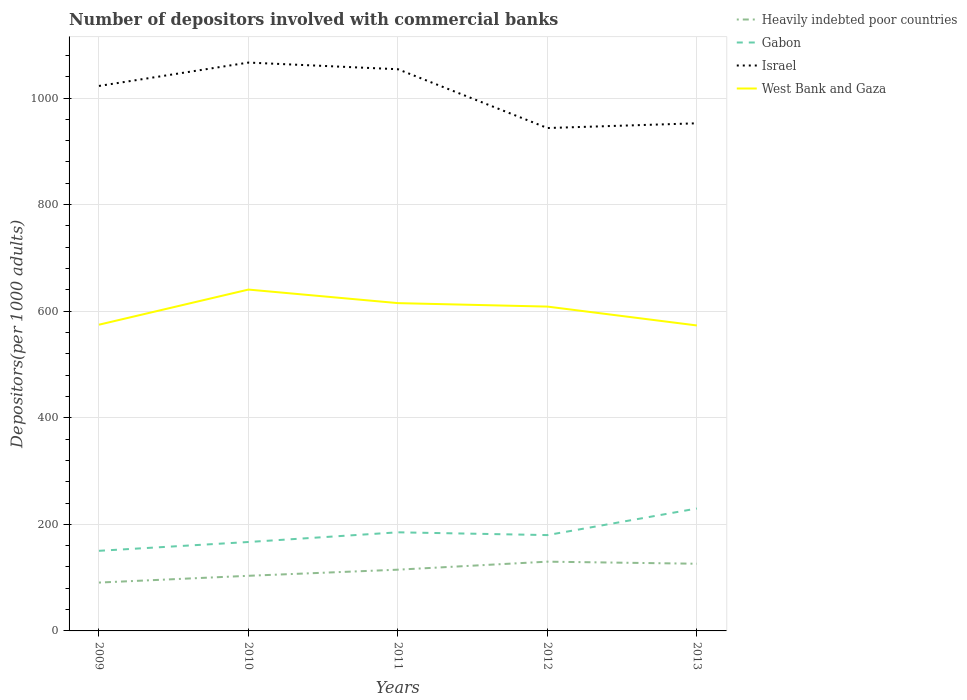How many different coloured lines are there?
Ensure brevity in your answer.  4. Does the line corresponding to Israel intersect with the line corresponding to Heavily indebted poor countries?
Make the answer very short. No. Across all years, what is the maximum number of depositors involved with commercial banks in West Bank and Gaza?
Provide a succinct answer. 573.23. In which year was the number of depositors involved with commercial banks in Israel maximum?
Offer a very short reply. 2012. What is the total number of depositors involved with commercial banks in West Bank and Gaza in the graph?
Your answer should be compact. -33.97. What is the difference between the highest and the second highest number of depositors involved with commercial banks in Gabon?
Offer a terse response. 79.41. Is the number of depositors involved with commercial banks in Israel strictly greater than the number of depositors involved with commercial banks in Heavily indebted poor countries over the years?
Provide a short and direct response. No. How many years are there in the graph?
Offer a terse response. 5. What is the difference between two consecutive major ticks on the Y-axis?
Offer a terse response. 200. Are the values on the major ticks of Y-axis written in scientific E-notation?
Provide a succinct answer. No. Does the graph contain grids?
Give a very brief answer. Yes. Where does the legend appear in the graph?
Ensure brevity in your answer.  Top right. How many legend labels are there?
Provide a short and direct response. 4. What is the title of the graph?
Give a very brief answer. Number of depositors involved with commercial banks. Does "Chile" appear as one of the legend labels in the graph?
Keep it short and to the point. No. What is the label or title of the X-axis?
Keep it short and to the point. Years. What is the label or title of the Y-axis?
Your answer should be very brief. Depositors(per 1000 adults). What is the Depositors(per 1000 adults) in Heavily indebted poor countries in 2009?
Give a very brief answer. 90.74. What is the Depositors(per 1000 adults) of Gabon in 2009?
Ensure brevity in your answer.  150.34. What is the Depositors(per 1000 adults) in Israel in 2009?
Offer a terse response. 1022.7. What is the Depositors(per 1000 adults) in West Bank and Gaza in 2009?
Your response must be concise. 574.67. What is the Depositors(per 1000 adults) of Heavily indebted poor countries in 2010?
Offer a terse response. 103.45. What is the Depositors(per 1000 adults) in Gabon in 2010?
Ensure brevity in your answer.  166.87. What is the Depositors(per 1000 adults) of Israel in 2010?
Provide a succinct answer. 1066.56. What is the Depositors(per 1000 adults) of West Bank and Gaza in 2010?
Keep it short and to the point. 640.58. What is the Depositors(per 1000 adults) in Heavily indebted poor countries in 2011?
Provide a short and direct response. 114.93. What is the Depositors(per 1000 adults) in Gabon in 2011?
Your answer should be very brief. 185.06. What is the Depositors(per 1000 adults) of Israel in 2011?
Make the answer very short. 1054.06. What is the Depositors(per 1000 adults) of West Bank and Gaza in 2011?
Give a very brief answer. 615.16. What is the Depositors(per 1000 adults) of Heavily indebted poor countries in 2012?
Your answer should be very brief. 129.98. What is the Depositors(per 1000 adults) in Gabon in 2012?
Offer a very short reply. 179.84. What is the Depositors(per 1000 adults) of Israel in 2012?
Your answer should be compact. 943.72. What is the Depositors(per 1000 adults) of West Bank and Gaza in 2012?
Your answer should be very brief. 608.64. What is the Depositors(per 1000 adults) of Heavily indebted poor countries in 2013?
Offer a very short reply. 126.07. What is the Depositors(per 1000 adults) in Gabon in 2013?
Offer a terse response. 229.74. What is the Depositors(per 1000 adults) of Israel in 2013?
Your response must be concise. 952.62. What is the Depositors(per 1000 adults) of West Bank and Gaza in 2013?
Your answer should be compact. 573.23. Across all years, what is the maximum Depositors(per 1000 adults) of Heavily indebted poor countries?
Provide a short and direct response. 129.98. Across all years, what is the maximum Depositors(per 1000 adults) in Gabon?
Offer a terse response. 229.74. Across all years, what is the maximum Depositors(per 1000 adults) in Israel?
Your response must be concise. 1066.56. Across all years, what is the maximum Depositors(per 1000 adults) in West Bank and Gaza?
Your answer should be very brief. 640.58. Across all years, what is the minimum Depositors(per 1000 adults) in Heavily indebted poor countries?
Provide a short and direct response. 90.74. Across all years, what is the minimum Depositors(per 1000 adults) of Gabon?
Your answer should be compact. 150.34. Across all years, what is the minimum Depositors(per 1000 adults) in Israel?
Your answer should be compact. 943.72. Across all years, what is the minimum Depositors(per 1000 adults) of West Bank and Gaza?
Offer a very short reply. 573.23. What is the total Depositors(per 1000 adults) in Heavily indebted poor countries in the graph?
Your answer should be compact. 565.17. What is the total Depositors(per 1000 adults) of Gabon in the graph?
Make the answer very short. 911.85. What is the total Depositors(per 1000 adults) in Israel in the graph?
Your answer should be compact. 5039.66. What is the total Depositors(per 1000 adults) of West Bank and Gaza in the graph?
Your answer should be very brief. 3012.28. What is the difference between the Depositors(per 1000 adults) in Heavily indebted poor countries in 2009 and that in 2010?
Provide a succinct answer. -12.71. What is the difference between the Depositors(per 1000 adults) in Gabon in 2009 and that in 2010?
Make the answer very short. -16.54. What is the difference between the Depositors(per 1000 adults) of Israel in 2009 and that in 2010?
Your answer should be very brief. -43.86. What is the difference between the Depositors(per 1000 adults) of West Bank and Gaza in 2009 and that in 2010?
Your response must be concise. -65.91. What is the difference between the Depositors(per 1000 adults) in Heavily indebted poor countries in 2009 and that in 2011?
Offer a very short reply. -24.2. What is the difference between the Depositors(per 1000 adults) in Gabon in 2009 and that in 2011?
Provide a succinct answer. -34.72. What is the difference between the Depositors(per 1000 adults) of Israel in 2009 and that in 2011?
Ensure brevity in your answer.  -31.36. What is the difference between the Depositors(per 1000 adults) in West Bank and Gaza in 2009 and that in 2011?
Offer a terse response. -40.49. What is the difference between the Depositors(per 1000 adults) of Heavily indebted poor countries in 2009 and that in 2012?
Your answer should be very brief. -39.24. What is the difference between the Depositors(per 1000 adults) of Gabon in 2009 and that in 2012?
Provide a succinct answer. -29.5. What is the difference between the Depositors(per 1000 adults) of Israel in 2009 and that in 2012?
Your answer should be very brief. 78.98. What is the difference between the Depositors(per 1000 adults) in West Bank and Gaza in 2009 and that in 2012?
Your response must be concise. -33.97. What is the difference between the Depositors(per 1000 adults) of Heavily indebted poor countries in 2009 and that in 2013?
Offer a very short reply. -35.33. What is the difference between the Depositors(per 1000 adults) in Gabon in 2009 and that in 2013?
Ensure brevity in your answer.  -79.41. What is the difference between the Depositors(per 1000 adults) in Israel in 2009 and that in 2013?
Keep it short and to the point. 70.08. What is the difference between the Depositors(per 1000 adults) in West Bank and Gaza in 2009 and that in 2013?
Offer a very short reply. 1.44. What is the difference between the Depositors(per 1000 adults) in Heavily indebted poor countries in 2010 and that in 2011?
Keep it short and to the point. -11.49. What is the difference between the Depositors(per 1000 adults) of Gabon in 2010 and that in 2011?
Ensure brevity in your answer.  -18.18. What is the difference between the Depositors(per 1000 adults) in Israel in 2010 and that in 2011?
Keep it short and to the point. 12.5. What is the difference between the Depositors(per 1000 adults) of West Bank and Gaza in 2010 and that in 2011?
Your response must be concise. 25.42. What is the difference between the Depositors(per 1000 adults) of Heavily indebted poor countries in 2010 and that in 2012?
Ensure brevity in your answer.  -26.54. What is the difference between the Depositors(per 1000 adults) in Gabon in 2010 and that in 2012?
Your answer should be compact. -12.97. What is the difference between the Depositors(per 1000 adults) of Israel in 2010 and that in 2012?
Keep it short and to the point. 122.84. What is the difference between the Depositors(per 1000 adults) in West Bank and Gaza in 2010 and that in 2012?
Keep it short and to the point. 31.94. What is the difference between the Depositors(per 1000 adults) in Heavily indebted poor countries in 2010 and that in 2013?
Make the answer very short. -22.63. What is the difference between the Depositors(per 1000 adults) in Gabon in 2010 and that in 2013?
Offer a very short reply. -62.87. What is the difference between the Depositors(per 1000 adults) of Israel in 2010 and that in 2013?
Make the answer very short. 113.94. What is the difference between the Depositors(per 1000 adults) in West Bank and Gaza in 2010 and that in 2013?
Your answer should be compact. 67.35. What is the difference between the Depositors(per 1000 adults) of Heavily indebted poor countries in 2011 and that in 2012?
Provide a short and direct response. -15.05. What is the difference between the Depositors(per 1000 adults) of Gabon in 2011 and that in 2012?
Keep it short and to the point. 5.22. What is the difference between the Depositors(per 1000 adults) of Israel in 2011 and that in 2012?
Provide a short and direct response. 110.33. What is the difference between the Depositors(per 1000 adults) of West Bank and Gaza in 2011 and that in 2012?
Make the answer very short. 6.52. What is the difference between the Depositors(per 1000 adults) in Heavily indebted poor countries in 2011 and that in 2013?
Offer a very short reply. -11.14. What is the difference between the Depositors(per 1000 adults) in Gabon in 2011 and that in 2013?
Keep it short and to the point. -44.69. What is the difference between the Depositors(per 1000 adults) of Israel in 2011 and that in 2013?
Ensure brevity in your answer.  101.44. What is the difference between the Depositors(per 1000 adults) of West Bank and Gaza in 2011 and that in 2013?
Provide a short and direct response. 41.92. What is the difference between the Depositors(per 1000 adults) of Heavily indebted poor countries in 2012 and that in 2013?
Make the answer very short. 3.91. What is the difference between the Depositors(per 1000 adults) of Gabon in 2012 and that in 2013?
Your answer should be very brief. -49.9. What is the difference between the Depositors(per 1000 adults) of Israel in 2012 and that in 2013?
Make the answer very short. -8.9. What is the difference between the Depositors(per 1000 adults) in West Bank and Gaza in 2012 and that in 2013?
Your answer should be very brief. 35.41. What is the difference between the Depositors(per 1000 adults) of Heavily indebted poor countries in 2009 and the Depositors(per 1000 adults) of Gabon in 2010?
Keep it short and to the point. -76.13. What is the difference between the Depositors(per 1000 adults) of Heavily indebted poor countries in 2009 and the Depositors(per 1000 adults) of Israel in 2010?
Your answer should be compact. -975.82. What is the difference between the Depositors(per 1000 adults) of Heavily indebted poor countries in 2009 and the Depositors(per 1000 adults) of West Bank and Gaza in 2010?
Your response must be concise. -549.84. What is the difference between the Depositors(per 1000 adults) in Gabon in 2009 and the Depositors(per 1000 adults) in Israel in 2010?
Offer a terse response. -916.22. What is the difference between the Depositors(per 1000 adults) of Gabon in 2009 and the Depositors(per 1000 adults) of West Bank and Gaza in 2010?
Provide a succinct answer. -490.24. What is the difference between the Depositors(per 1000 adults) in Israel in 2009 and the Depositors(per 1000 adults) in West Bank and Gaza in 2010?
Give a very brief answer. 382.12. What is the difference between the Depositors(per 1000 adults) of Heavily indebted poor countries in 2009 and the Depositors(per 1000 adults) of Gabon in 2011?
Ensure brevity in your answer.  -94.32. What is the difference between the Depositors(per 1000 adults) in Heavily indebted poor countries in 2009 and the Depositors(per 1000 adults) in Israel in 2011?
Give a very brief answer. -963.32. What is the difference between the Depositors(per 1000 adults) of Heavily indebted poor countries in 2009 and the Depositors(per 1000 adults) of West Bank and Gaza in 2011?
Your response must be concise. -524.42. What is the difference between the Depositors(per 1000 adults) in Gabon in 2009 and the Depositors(per 1000 adults) in Israel in 2011?
Keep it short and to the point. -903.72. What is the difference between the Depositors(per 1000 adults) in Gabon in 2009 and the Depositors(per 1000 adults) in West Bank and Gaza in 2011?
Offer a terse response. -464.82. What is the difference between the Depositors(per 1000 adults) in Israel in 2009 and the Depositors(per 1000 adults) in West Bank and Gaza in 2011?
Offer a terse response. 407.54. What is the difference between the Depositors(per 1000 adults) of Heavily indebted poor countries in 2009 and the Depositors(per 1000 adults) of Gabon in 2012?
Give a very brief answer. -89.1. What is the difference between the Depositors(per 1000 adults) in Heavily indebted poor countries in 2009 and the Depositors(per 1000 adults) in Israel in 2012?
Offer a terse response. -852.99. What is the difference between the Depositors(per 1000 adults) of Heavily indebted poor countries in 2009 and the Depositors(per 1000 adults) of West Bank and Gaza in 2012?
Your answer should be compact. -517.9. What is the difference between the Depositors(per 1000 adults) of Gabon in 2009 and the Depositors(per 1000 adults) of Israel in 2012?
Offer a terse response. -793.39. What is the difference between the Depositors(per 1000 adults) in Gabon in 2009 and the Depositors(per 1000 adults) in West Bank and Gaza in 2012?
Keep it short and to the point. -458.3. What is the difference between the Depositors(per 1000 adults) in Israel in 2009 and the Depositors(per 1000 adults) in West Bank and Gaza in 2012?
Make the answer very short. 414.06. What is the difference between the Depositors(per 1000 adults) in Heavily indebted poor countries in 2009 and the Depositors(per 1000 adults) in Gabon in 2013?
Keep it short and to the point. -139. What is the difference between the Depositors(per 1000 adults) of Heavily indebted poor countries in 2009 and the Depositors(per 1000 adults) of Israel in 2013?
Offer a terse response. -861.88. What is the difference between the Depositors(per 1000 adults) in Heavily indebted poor countries in 2009 and the Depositors(per 1000 adults) in West Bank and Gaza in 2013?
Offer a very short reply. -482.49. What is the difference between the Depositors(per 1000 adults) in Gabon in 2009 and the Depositors(per 1000 adults) in Israel in 2013?
Make the answer very short. -802.28. What is the difference between the Depositors(per 1000 adults) in Gabon in 2009 and the Depositors(per 1000 adults) in West Bank and Gaza in 2013?
Offer a very short reply. -422.9. What is the difference between the Depositors(per 1000 adults) in Israel in 2009 and the Depositors(per 1000 adults) in West Bank and Gaza in 2013?
Offer a very short reply. 449.47. What is the difference between the Depositors(per 1000 adults) of Heavily indebted poor countries in 2010 and the Depositors(per 1000 adults) of Gabon in 2011?
Keep it short and to the point. -81.61. What is the difference between the Depositors(per 1000 adults) in Heavily indebted poor countries in 2010 and the Depositors(per 1000 adults) in Israel in 2011?
Offer a terse response. -950.61. What is the difference between the Depositors(per 1000 adults) of Heavily indebted poor countries in 2010 and the Depositors(per 1000 adults) of West Bank and Gaza in 2011?
Ensure brevity in your answer.  -511.71. What is the difference between the Depositors(per 1000 adults) in Gabon in 2010 and the Depositors(per 1000 adults) in Israel in 2011?
Your response must be concise. -887.18. What is the difference between the Depositors(per 1000 adults) of Gabon in 2010 and the Depositors(per 1000 adults) of West Bank and Gaza in 2011?
Ensure brevity in your answer.  -448.28. What is the difference between the Depositors(per 1000 adults) of Israel in 2010 and the Depositors(per 1000 adults) of West Bank and Gaza in 2011?
Your answer should be compact. 451.4. What is the difference between the Depositors(per 1000 adults) in Heavily indebted poor countries in 2010 and the Depositors(per 1000 adults) in Gabon in 2012?
Give a very brief answer. -76.4. What is the difference between the Depositors(per 1000 adults) of Heavily indebted poor countries in 2010 and the Depositors(per 1000 adults) of Israel in 2012?
Your response must be concise. -840.28. What is the difference between the Depositors(per 1000 adults) in Heavily indebted poor countries in 2010 and the Depositors(per 1000 adults) in West Bank and Gaza in 2012?
Give a very brief answer. -505.19. What is the difference between the Depositors(per 1000 adults) of Gabon in 2010 and the Depositors(per 1000 adults) of Israel in 2012?
Keep it short and to the point. -776.85. What is the difference between the Depositors(per 1000 adults) in Gabon in 2010 and the Depositors(per 1000 adults) in West Bank and Gaza in 2012?
Provide a short and direct response. -441.77. What is the difference between the Depositors(per 1000 adults) of Israel in 2010 and the Depositors(per 1000 adults) of West Bank and Gaza in 2012?
Offer a terse response. 457.92. What is the difference between the Depositors(per 1000 adults) in Heavily indebted poor countries in 2010 and the Depositors(per 1000 adults) in Gabon in 2013?
Provide a short and direct response. -126.3. What is the difference between the Depositors(per 1000 adults) of Heavily indebted poor countries in 2010 and the Depositors(per 1000 adults) of Israel in 2013?
Provide a succinct answer. -849.18. What is the difference between the Depositors(per 1000 adults) in Heavily indebted poor countries in 2010 and the Depositors(per 1000 adults) in West Bank and Gaza in 2013?
Your answer should be very brief. -469.79. What is the difference between the Depositors(per 1000 adults) in Gabon in 2010 and the Depositors(per 1000 adults) in Israel in 2013?
Your answer should be compact. -785.75. What is the difference between the Depositors(per 1000 adults) of Gabon in 2010 and the Depositors(per 1000 adults) of West Bank and Gaza in 2013?
Provide a succinct answer. -406.36. What is the difference between the Depositors(per 1000 adults) in Israel in 2010 and the Depositors(per 1000 adults) in West Bank and Gaza in 2013?
Your response must be concise. 493.33. What is the difference between the Depositors(per 1000 adults) in Heavily indebted poor countries in 2011 and the Depositors(per 1000 adults) in Gabon in 2012?
Offer a very short reply. -64.91. What is the difference between the Depositors(per 1000 adults) in Heavily indebted poor countries in 2011 and the Depositors(per 1000 adults) in Israel in 2012?
Provide a succinct answer. -828.79. What is the difference between the Depositors(per 1000 adults) of Heavily indebted poor countries in 2011 and the Depositors(per 1000 adults) of West Bank and Gaza in 2012?
Provide a succinct answer. -493.71. What is the difference between the Depositors(per 1000 adults) of Gabon in 2011 and the Depositors(per 1000 adults) of Israel in 2012?
Provide a short and direct response. -758.67. What is the difference between the Depositors(per 1000 adults) in Gabon in 2011 and the Depositors(per 1000 adults) in West Bank and Gaza in 2012?
Your response must be concise. -423.58. What is the difference between the Depositors(per 1000 adults) in Israel in 2011 and the Depositors(per 1000 adults) in West Bank and Gaza in 2012?
Offer a very short reply. 445.42. What is the difference between the Depositors(per 1000 adults) in Heavily indebted poor countries in 2011 and the Depositors(per 1000 adults) in Gabon in 2013?
Your response must be concise. -114.81. What is the difference between the Depositors(per 1000 adults) in Heavily indebted poor countries in 2011 and the Depositors(per 1000 adults) in Israel in 2013?
Make the answer very short. -837.69. What is the difference between the Depositors(per 1000 adults) in Heavily indebted poor countries in 2011 and the Depositors(per 1000 adults) in West Bank and Gaza in 2013?
Offer a terse response. -458.3. What is the difference between the Depositors(per 1000 adults) in Gabon in 2011 and the Depositors(per 1000 adults) in Israel in 2013?
Provide a short and direct response. -767.56. What is the difference between the Depositors(per 1000 adults) of Gabon in 2011 and the Depositors(per 1000 adults) of West Bank and Gaza in 2013?
Ensure brevity in your answer.  -388.18. What is the difference between the Depositors(per 1000 adults) of Israel in 2011 and the Depositors(per 1000 adults) of West Bank and Gaza in 2013?
Offer a very short reply. 480.82. What is the difference between the Depositors(per 1000 adults) in Heavily indebted poor countries in 2012 and the Depositors(per 1000 adults) in Gabon in 2013?
Give a very brief answer. -99.76. What is the difference between the Depositors(per 1000 adults) of Heavily indebted poor countries in 2012 and the Depositors(per 1000 adults) of Israel in 2013?
Your response must be concise. -822.64. What is the difference between the Depositors(per 1000 adults) in Heavily indebted poor countries in 2012 and the Depositors(per 1000 adults) in West Bank and Gaza in 2013?
Your answer should be compact. -443.25. What is the difference between the Depositors(per 1000 adults) of Gabon in 2012 and the Depositors(per 1000 adults) of Israel in 2013?
Keep it short and to the point. -772.78. What is the difference between the Depositors(per 1000 adults) of Gabon in 2012 and the Depositors(per 1000 adults) of West Bank and Gaza in 2013?
Offer a very short reply. -393.39. What is the difference between the Depositors(per 1000 adults) of Israel in 2012 and the Depositors(per 1000 adults) of West Bank and Gaza in 2013?
Ensure brevity in your answer.  370.49. What is the average Depositors(per 1000 adults) in Heavily indebted poor countries per year?
Offer a terse response. 113.03. What is the average Depositors(per 1000 adults) of Gabon per year?
Offer a terse response. 182.37. What is the average Depositors(per 1000 adults) in Israel per year?
Provide a short and direct response. 1007.93. What is the average Depositors(per 1000 adults) of West Bank and Gaza per year?
Offer a terse response. 602.46. In the year 2009, what is the difference between the Depositors(per 1000 adults) in Heavily indebted poor countries and Depositors(per 1000 adults) in Gabon?
Keep it short and to the point. -59.6. In the year 2009, what is the difference between the Depositors(per 1000 adults) of Heavily indebted poor countries and Depositors(per 1000 adults) of Israel?
Offer a terse response. -931.96. In the year 2009, what is the difference between the Depositors(per 1000 adults) of Heavily indebted poor countries and Depositors(per 1000 adults) of West Bank and Gaza?
Provide a short and direct response. -483.93. In the year 2009, what is the difference between the Depositors(per 1000 adults) in Gabon and Depositors(per 1000 adults) in Israel?
Make the answer very short. -872.36. In the year 2009, what is the difference between the Depositors(per 1000 adults) in Gabon and Depositors(per 1000 adults) in West Bank and Gaza?
Offer a very short reply. -424.33. In the year 2009, what is the difference between the Depositors(per 1000 adults) of Israel and Depositors(per 1000 adults) of West Bank and Gaza?
Offer a terse response. 448.03. In the year 2010, what is the difference between the Depositors(per 1000 adults) of Heavily indebted poor countries and Depositors(per 1000 adults) of Gabon?
Give a very brief answer. -63.43. In the year 2010, what is the difference between the Depositors(per 1000 adults) of Heavily indebted poor countries and Depositors(per 1000 adults) of Israel?
Provide a succinct answer. -963.12. In the year 2010, what is the difference between the Depositors(per 1000 adults) in Heavily indebted poor countries and Depositors(per 1000 adults) in West Bank and Gaza?
Offer a terse response. -537.13. In the year 2010, what is the difference between the Depositors(per 1000 adults) in Gabon and Depositors(per 1000 adults) in Israel?
Offer a very short reply. -899.69. In the year 2010, what is the difference between the Depositors(per 1000 adults) in Gabon and Depositors(per 1000 adults) in West Bank and Gaza?
Make the answer very short. -473.71. In the year 2010, what is the difference between the Depositors(per 1000 adults) in Israel and Depositors(per 1000 adults) in West Bank and Gaza?
Your response must be concise. 425.98. In the year 2011, what is the difference between the Depositors(per 1000 adults) in Heavily indebted poor countries and Depositors(per 1000 adults) in Gabon?
Make the answer very short. -70.12. In the year 2011, what is the difference between the Depositors(per 1000 adults) in Heavily indebted poor countries and Depositors(per 1000 adults) in Israel?
Provide a short and direct response. -939.12. In the year 2011, what is the difference between the Depositors(per 1000 adults) in Heavily indebted poor countries and Depositors(per 1000 adults) in West Bank and Gaza?
Your answer should be very brief. -500.22. In the year 2011, what is the difference between the Depositors(per 1000 adults) of Gabon and Depositors(per 1000 adults) of Israel?
Provide a short and direct response. -869. In the year 2011, what is the difference between the Depositors(per 1000 adults) in Gabon and Depositors(per 1000 adults) in West Bank and Gaza?
Keep it short and to the point. -430.1. In the year 2011, what is the difference between the Depositors(per 1000 adults) of Israel and Depositors(per 1000 adults) of West Bank and Gaza?
Offer a terse response. 438.9. In the year 2012, what is the difference between the Depositors(per 1000 adults) of Heavily indebted poor countries and Depositors(per 1000 adults) of Gabon?
Offer a terse response. -49.86. In the year 2012, what is the difference between the Depositors(per 1000 adults) in Heavily indebted poor countries and Depositors(per 1000 adults) in Israel?
Provide a short and direct response. -813.74. In the year 2012, what is the difference between the Depositors(per 1000 adults) of Heavily indebted poor countries and Depositors(per 1000 adults) of West Bank and Gaza?
Keep it short and to the point. -478.66. In the year 2012, what is the difference between the Depositors(per 1000 adults) of Gabon and Depositors(per 1000 adults) of Israel?
Give a very brief answer. -763.88. In the year 2012, what is the difference between the Depositors(per 1000 adults) of Gabon and Depositors(per 1000 adults) of West Bank and Gaza?
Give a very brief answer. -428.8. In the year 2012, what is the difference between the Depositors(per 1000 adults) in Israel and Depositors(per 1000 adults) in West Bank and Gaza?
Keep it short and to the point. 335.08. In the year 2013, what is the difference between the Depositors(per 1000 adults) in Heavily indebted poor countries and Depositors(per 1000 adults) in Gabon?
Ensure brevity in your answer.  -103.67. In the year 2013, what is the difference between the Depositors(per 1000 adults) in Heavily indebted poor countries and Depositors(per 1000 adults) in Israel?
Your answer should be compact. -826.55. In the year 2013, what is the difference between the Depositors(per 1000 adults) of Heavily indebted poor countries and Depositors(per 1000 adults) of West Bank and Gaza?
Offer a terse response. -447.16. In the year 2013, what is the difference between the Depositors(per 1000 adults) in Gabon and Depositors(per 1000 adults) in Israel?
Your response must be concise. -722.88. In the year 2013, what is the difference between the Depositors(per 1000 adults) in Gabon and Depositors(per 1000 adults) in West Bank and Gaza?
Provide a succinct answer. -343.49. In the year 2013, what is the difference between the Depositors(per 1000 adults) in Israel and Depositors(per 1000 adults) in West Bank and Gaza?
Ensure brevity in your answer.  379.39. What is the ratio of the Depositors(per 1000 adults) of Heavily indebted poor countries in 2009 to that in 2010?
Your response must be concise. 0.88. What is the ratio of the Depositors(per 1000 adults) in Gabon in 2009 to that in 2010?
Your answer should be very brief. 0.9. What is the ratio of the Depositors(per 1000 adults) of Israel in 2009 to that in 2010?
Your answer should be very brief. 0.96. What is the ratio of the Depositors(per 1000 adults) of West Bank and Gaza in 2009 to that in 2010?
Make the answer very short. 0.9. What is the ratio of the Depositors(per 1000 adults) in Heavily indebted poor countries in 2009 to that in 2011?
Make the answer very short. 0.79. What is the ratio of the Depositors(per 1000 adults) of Gabon in 2009 to that in 2011?
Provide a succinct answer. 0.81. What is the ratio of the Depositors(per 1000 adults) in Israel in 2009 to that in 2011?
Your answer should be very brief. 0.97. What is the ratio of the Depositors(per 1000 adults) in West Bank and Gaza in 2009 to that in 2011?
Make the answer very short. 0.93. What is the ratio of the Depositors(per 1000 adults) of Heavily indebted poor countries in 2009 to that in 2012?
Give a very brief answer. 0.7. What is the ratio of the Depositors(per 1000 adults) in Gabon in 2009 to that in 2012?
Offer a terse response. 0.84. What is the ratio of the Depositors(per 1000 adults) of Israel in 2009 to that in 2012?
Give a very brief answer. 1.08. What is the ratio of the Depositors(per 1000 adults) in West Bank and Gaza in 2009 to that in 2012?
Offer a terse response. 0.94. What is the ratio of the Depositors(per 1000 adults) of Heavily indebted poor countries in 2009 to that in 2013?
Provide a succinct answer. 0.72. What is the ratio of the Depositors(per 1000 adults) of Gabon in 2009 to that in 2013?
Your answer should be compact. 0.65. What is the ratio of the Depositors(per 1000 adults) in Israel in 2009 to that in 2013?
Your answer should be very brief. 1.07. What is the ratio of the Depositors(per 1000 adults) of West Bank and Gaza in 2009 to that in 2013?
Provide a succinct answer. 1. What is the ratio of the Depositors(per 1000 adults) of Heavily indebted poor countries in 2010 to that in 2011?
Your response must be concise. 0.9. What is the ratio of the Depositors(per 1000 adults) of Gabon in 2010 to that in 2011?
Your response must be concise. 0.9. What is the ratio of the Depositors(per 1000 adults) in Israel in 2010 to that in 2011?
Offer a terse response. 1.01. What is the ratio of the Depositors(per 1000 adults) of West Bank and Gaza in 2010 to that in 2011?
Keep it short and to the point. 1.04. What is the ratio of the Depositors(per 1000 adults) in Heavily indebted poor countries in 2010 to that in 2012?
Your answer should be compact. 0.8. What is the ratio of the Depositors(per 1000 adults) in Gabon in 2010 to that in 2012?
Offer a terse response. 0.93. What is the ratio of the Depositors(per 1000 adults) in Israel in 2010 to that in 2012?
Make the answer very short. 1.13. What is the ratio of the Depositors(per 1000 adults) of West Bank and Gaza in 2010 to that in 2012?
Your answer should be compact. 1.05. What is the ratio of the Depositors(per 1000 adults) of Heavily indebted poor countries in 2010 to that in 2013?
Give a very brief answer. 0.82. What is the ratio of the Depositors(per 1000 adults) of Gabon in 2010 to that in 2013?
Offer a very short reply. 0.73. What is the ratio of the Depositors(per 1000 adults) of Israel in 2010 to that in 2013?
Provide a succinct answer. 1.12. What is the ratio of the Depositors(per 1000 adults) in West Bank and Gaza in 2010 to that in 2013?
Provide a short and direct response. 1.12. What is the ratio of the Depositors(per 1000 adults) of Heavily indebted poor countries in 2011 to that in 2012?
Offer a very short reply. 0.88. What is the ratio of the Depositors(per 1000 adults) in Gabon in 2011 to that in 2012?
Offer a very short reply. 1.03. What is the ratio of the Depositors(per 1000 adults) in Israel in 2011 to that in 2012?
Ensure brevity in your answer.  1.12. What is the ratio of the Depositors(per 1000 adults) of West Bank and Gaza in 2011 to that in 2012?
Ensure brevity in your answer.  1.01. What is the ratio of the Depositors(per 1000 adults) of Heavily indebted poor countries in 2011 to that in 2013?
Give a very brief answer. 0.91. What is the ratio of the Depositors(per 1000 adults) of Gabon in 2011 to that in 2013?
Your answer should be very brief. 0.81. What is the ratio of the Depositors(per 1000 adults) in Israel in 2011 to that in 2013?
Your response must be concise. 1.11. What is the ratio of the Depositors(per 1000 adults) of West Bank and Gaza in 2011 to that in 2013?
Offer a terse response. 1.07. What is the ratio of the Depositors(per 1000 adults) in Heavily indebted poor countries in 2012 to that in 2013?
Keep it short and to the point. 1.03. What is the ratio of the Depositors(per 1000 adults) of Gabon in 2012 to that in 2013?
Keep it short and to the point. 0.78. What is the ratio of the Depositors(per 1000 adults) of Israel in 2012 to that in 2013?
Provide a short and direct response. 0.99. What is the ratio of the Depositors(per 1000 adults) of West Bank and Gaza in 2012 to that in 2013?
Your answer should be very brief. 1.06. What is the difference between the highest and the second highest Depositors(per 1000 adults) in Heavily indebted poor countries?
Offer a terse response. 3.91. What is the difference between the highest and the second highest Depositors(per 1000 adults) of Gabon?
Your response must be concise. 44.69. What is the difference between the highest and the second highest Depositors(per 1000 adults) in Israel?
Keep it short and to the point. 12.5. What is the difference between the highest and the second highest Depositors(per 1000 adults) of West Bank and Gaza?
Provide a succinct answer. 25.42. What is the difference between the highest and the lowest Depositors(per 1000 adults) of Heavily indebted poor countries?
Your answer should be compact. 39.24. What is the difference between the highest and the lowest Depositors(per 1000 adults) in Gabon?
Give a very brief answer. 79.41. What is the difference between the highest and the lowest Depositors(per 1000 adults) in Israel?
Make the answer very short. 122.84. What is the difference between the highest and the lowest Depositors(per 1000 adults) in West Bank and Gaza?
Provide a succinct answer. 67.35. 